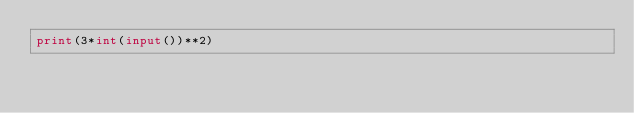<code> <loc_0><loc_0><loc_500><loc_500><_Python_>print(3*int(input())**2)</code> 